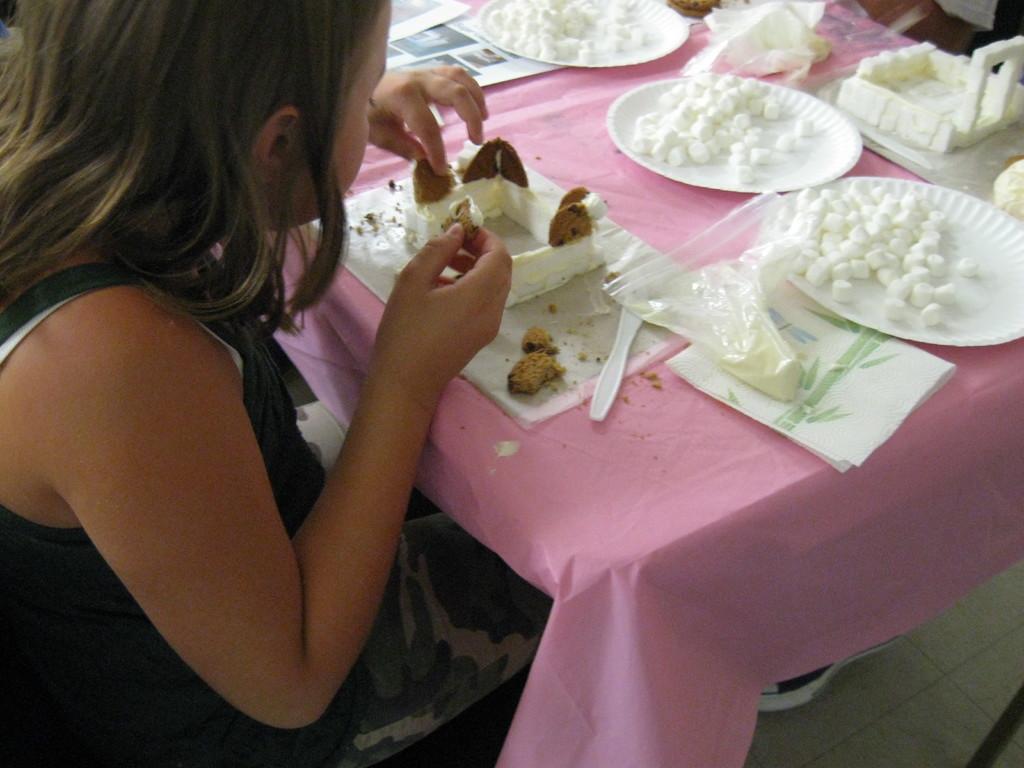Could you give a brief overview of what you see in this image? This picture is clicked inside room. On the left corner of this picture, we see a girl in black t-shirt is sitting on the chair before the table and having her food. On the table, we see plate, spoon, plastic cover, tissue and this table is covered with a pink color cloth. On table, we even see some paper. 